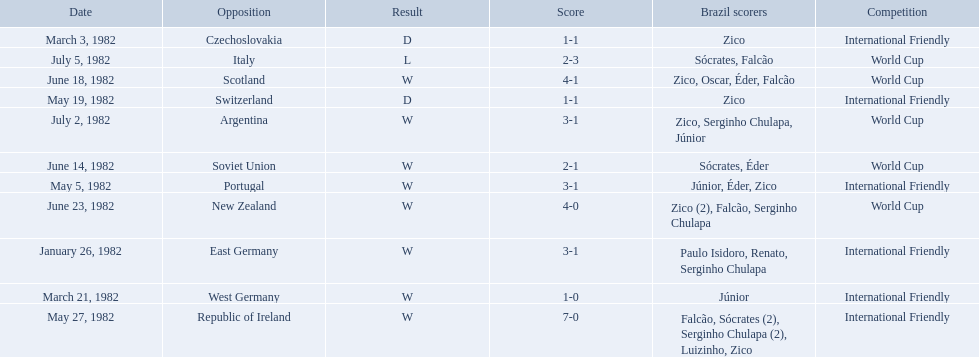Who did brazil play against Soviet Union. Who scored the most goals? Portugal. 